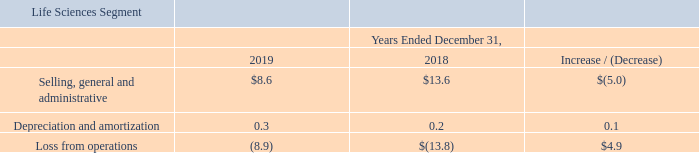Life Sciences Segment
Selling, general and administrative: Selling, general and administrative expenses from our Life Sciences segment for the year ended December 31, 2019 decreased $5.0 million to $8.6 million from $13.6 million for the year ended December 31, 2018. The decrease was driven by comparably fewer expenses at the Pansend holding company, which incurred additional compensation expense in the prior period related to the performance of the segment. The decrease was also due to a reduction in costs associated with the sale of BeneVir in the second quarter of 2018.
What was the Selling, general and administrative expenses from our Life Sciences segment for the year ended December 31, 2019? $8.6 million. What was the decrease in the selling, general and administrative expenses? $5.0 million. What was the reason for the decrease in the selling, general and administrative expenses? The decrease was driven by comparably fewer expenses at the pansend holding company, which incurred additional compensation expense in the prior period related to the performance of the segment. the decrease was also due to a reduction in costs associated with the sale of benevir in the second quarter of 2018. What was the percentage increase / (decrease) in the selling, general and administrative expenses from 2018 to 2019?
Answer scale should be: percent. 8.6 / 13.6 - 1
Answer: -36.76. What was the average depreciation and amortization expense?
Answer scale should be: million. (0.3 + 0.2) / 2
Answer: 0.25. What was the percentage increase / (decrease) in the loss from operations from 2018 to 2019?
Answer scale should be: percent. -8.9 / -13.8 - 1
Answer: -35.51. 